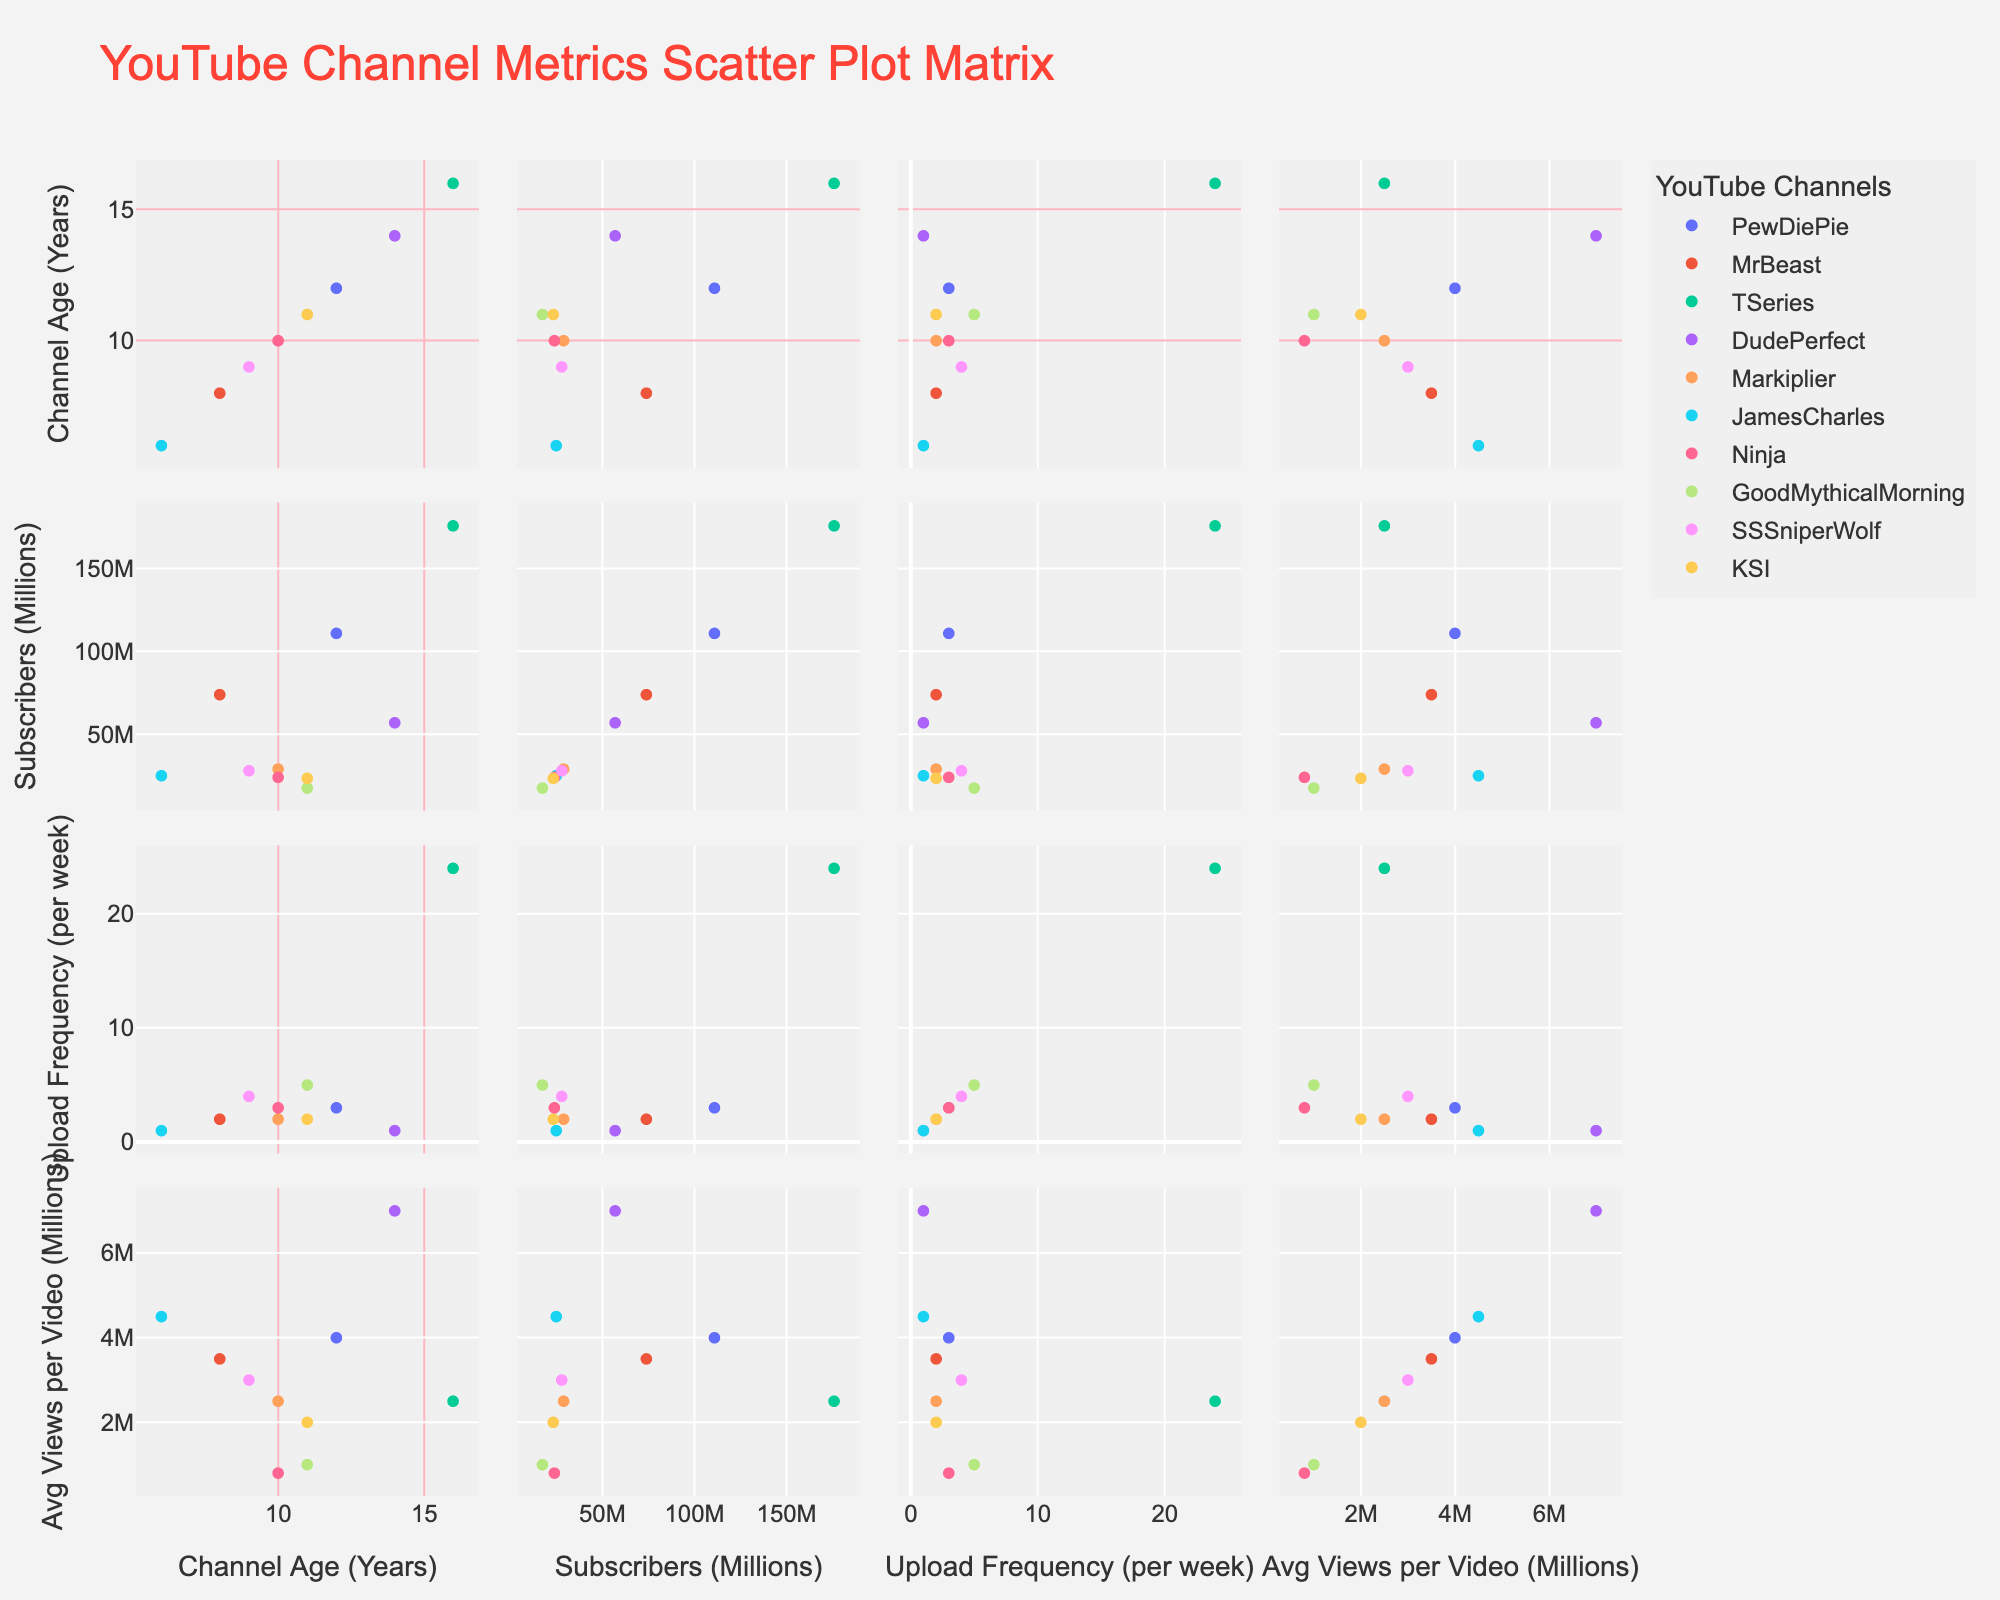What is the title of the plot? The title is usually displayed at the top of the plot and is meant to summarize the content of the figure. In this case, it should indicate that the plot is about YouTube Channel Metrics.
Answer: YouTube Channel Metrics Scatter Plot Matrix How many YouTube channels are represented in the plot? Each data point in the SPLOM represents a YouTube channel. By counting the distinct colors or the hover names, one can determine the number.
Answer: 10 Which channel has the highest number of subscribers? By examining the Subscribers axis across the plot and identifying the highest point, we can determine which channel has the maximum subscribers.
Answer: TSeries What is the correlation between Upload Frequency and Average Views Per Video for Good Mythical Morning? To determine this, observe the scatter plot where Upload Frequency and Average Views Per Video are the axes and find the position of Good Mythical Morning. Seeing if there's a trend can indicate correlation.
Answer: No clear trend Which two channels have similar Upload Frequency but different average views per video? Look for points that are vertically aligned (same Upload Frequency) but have different positions along the Average Views Per Video axis.
Answer: MrBeast and Ninja How does the age of the channel relate to the number of subscribers? Examine the scatter plots with AgeInYears and Subscribers axes to see if older channels generally have more or fewer subscribers.
Answer: Older channels generally have more subscribers What is the relationship between upload frequency and subscriber count for Ninja and Markiplier? Compare the data points for both channels in the Upload Frequency vs. Subscribers plot to see if higher upload frequency corresponds to higher subscriber count for these two.
Answer: Ninja has higher upload frequency but fewer subscribers than Markiplier Which channel has the highest average views per video? By examining the Average Views Per Video axis across the plot and identifying the highest point, you can determine the channel with the highest average views.
Answer: DudePerfect Is there any visible trend between channel age and upload frequency? Observe the scatter plot where AgeInYears and UploadFrequency are the axes to determine if older or younger channels tend to upload more frequently.
Answer: No clear trend How does SSSniperWolf’s upload frequency compare to James Charles’? Locate the data points for these two channels in terms of Upload Frequency and compare their vertical positions.
Answer: SSSniperWolf uploads more frequently than James Charles 